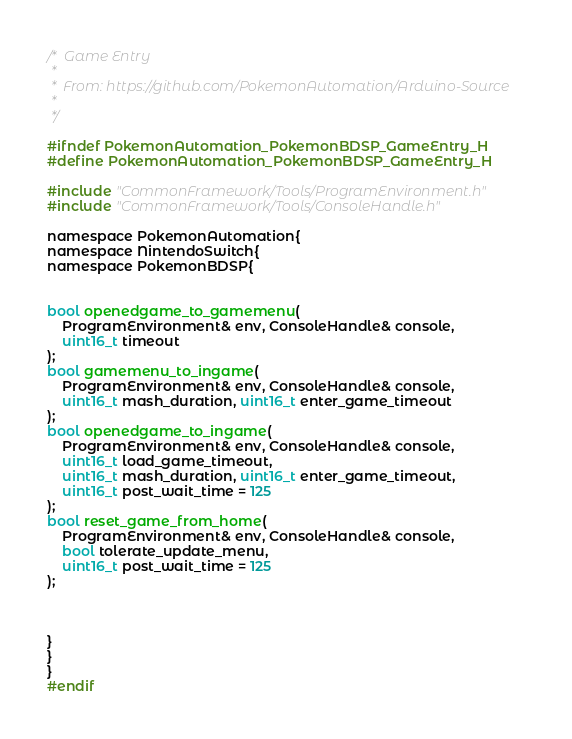<code> <loc_0><loc_0><loc_500><loc_500><_C_>/*  Game Entry
 *
 *  From: https://github.com/PokemonAutomation/Arduino-Source
 *
 */

#ifndef PokemonAutomation_PokemonBDSP_GameEntry_H
#define PokemonAutomation_PokemonBDSP_GameEntry_H

#include "CommonFramework/Tools/ProgramEnvironment.h"
#include "CommonFramework/Tools/ConsoleHandle.h"

namespace PokemonAutomation{
namespace NintendoSwitch{
namespace PokemonBDSP{


bool openedgame_to_gamemenu(
    ProgramEnvironment& env, ConsoleHandle& console,
    uint16_t timeout
);
bool gamemenu_to_ingame(
    ProgramEnvironment& env, ConsoleHandle& console,
    uint16_t mash_duration, uint16_t enter_game_timeout
);
bool openedgame_to_ingame(
    ProgramEnvironment& env, ConsoleHandle& console,
    uint16_t load_game_timeout,
    uint16_t mash_duration, uint16_t enter_game_timeout,
    uint16_t post_wait_time = 125
);
bool reset_game_from_home(
    ProgramEnvironment& env, ConsoleHandle& console,
    bool tolerate_update_menu,
    uint16_t post_wait_time = 125
);



}
}
}
#endif
</code> 